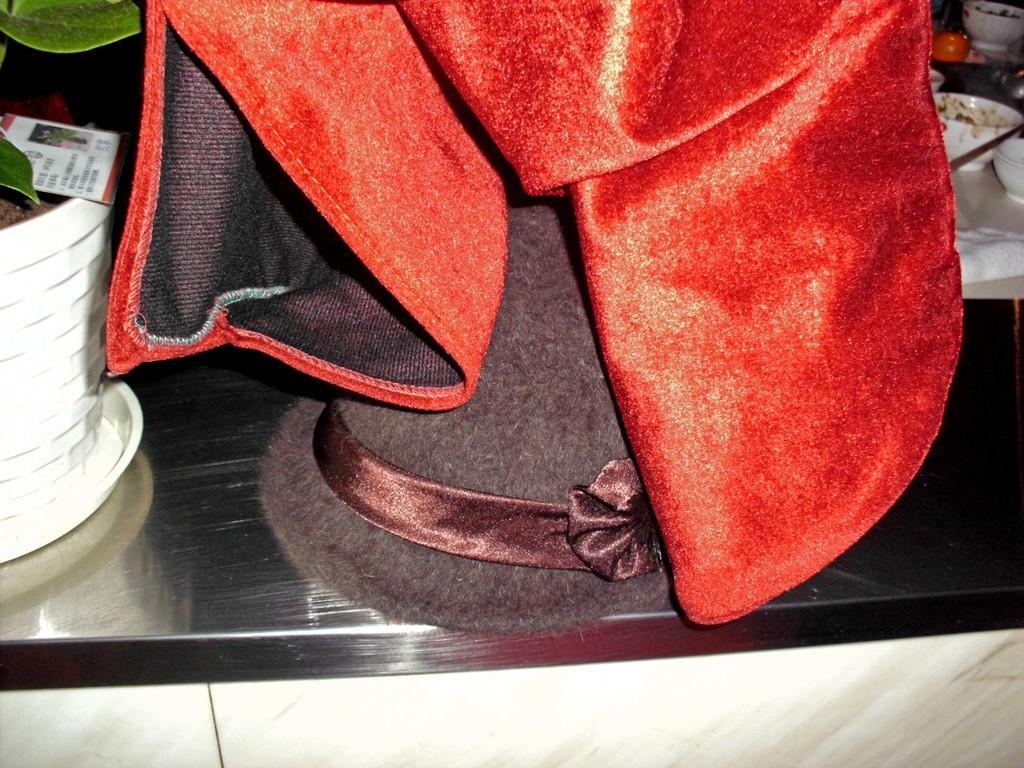Can you describe this image briefly? In this image there is a cabinet on that there is a hat, cloth and a plant pot and there are some bowls. 